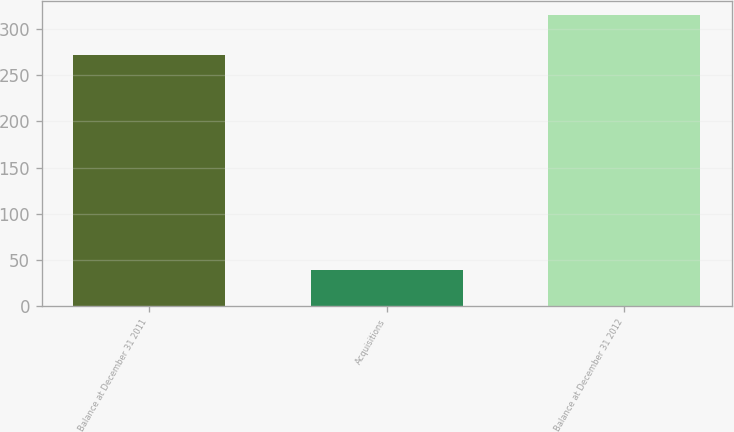Convert chart to OTSL. <chart><loc_0><loc_0><loc_500><loc_500><bar_chart><fcel>Balance at December 31 2011<fcel>Acquisitions<fcel>Balance at December 31 2012<nl><fcel>272<fcel>39<fcel>315<nl></chart> 